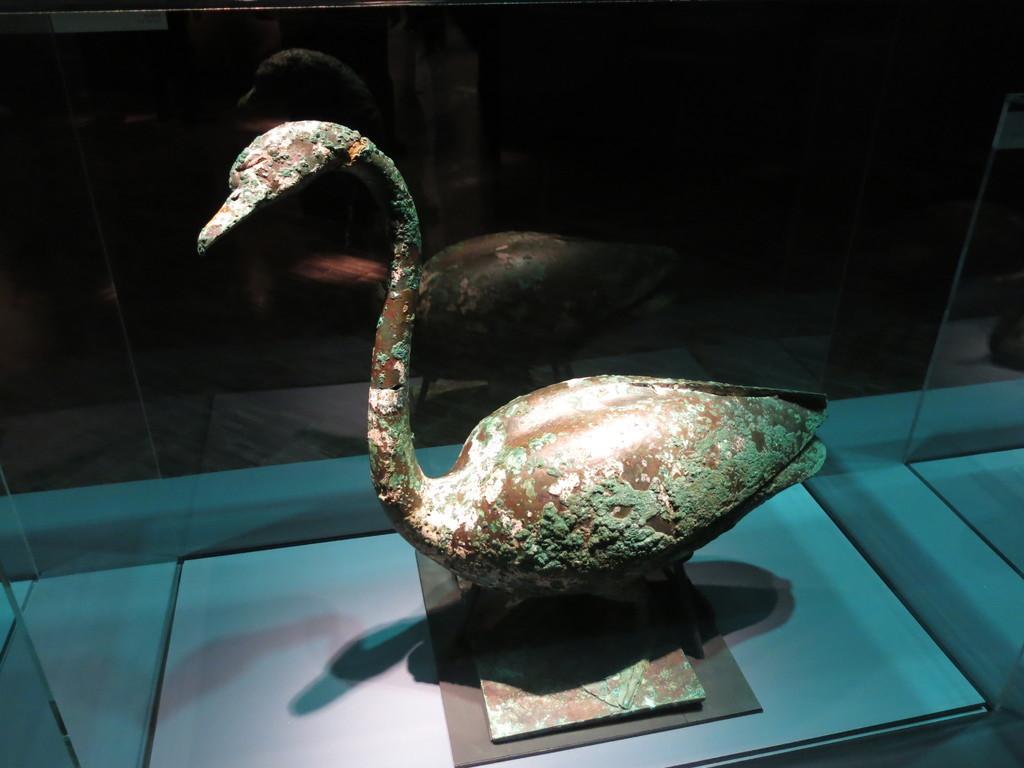Can you describe this image briefly? Here we can see an ancient duck sculpture on a platform in a glass box. 